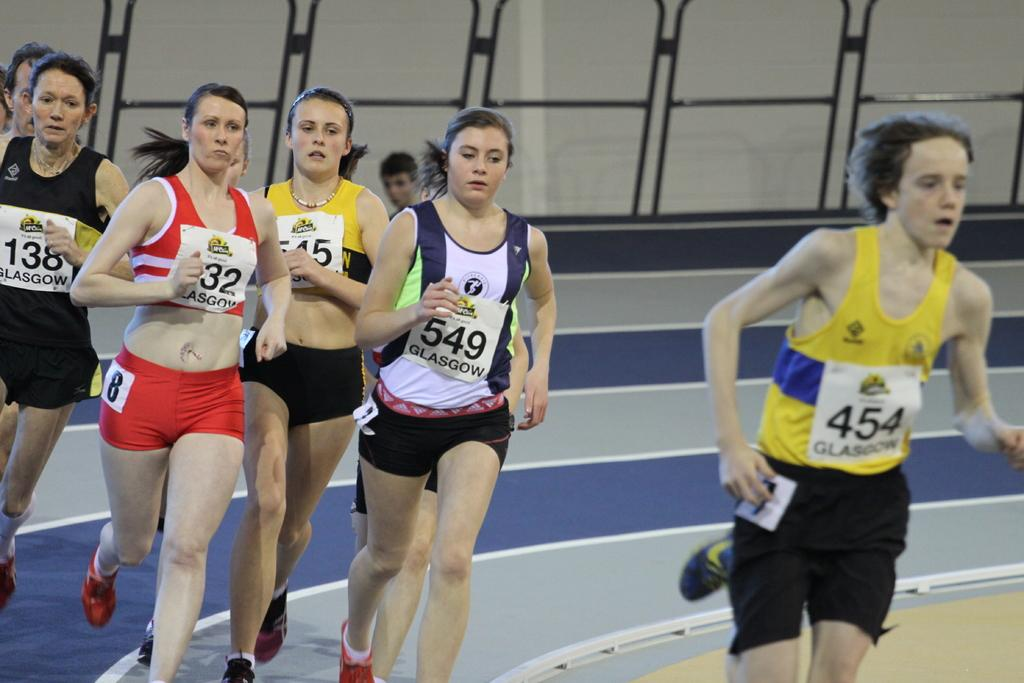<image>
Give a short and clear explanation of the subsequent image. A group of people are running at an indoor track and the person in the lead is number 454. 